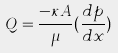Convert formula to latex. <formula><loc_0><loc_0><loc_500><loc_500>Q = \frac { - \kappa A } { \mu } ( \frac { d p } { d x } )</formula> 